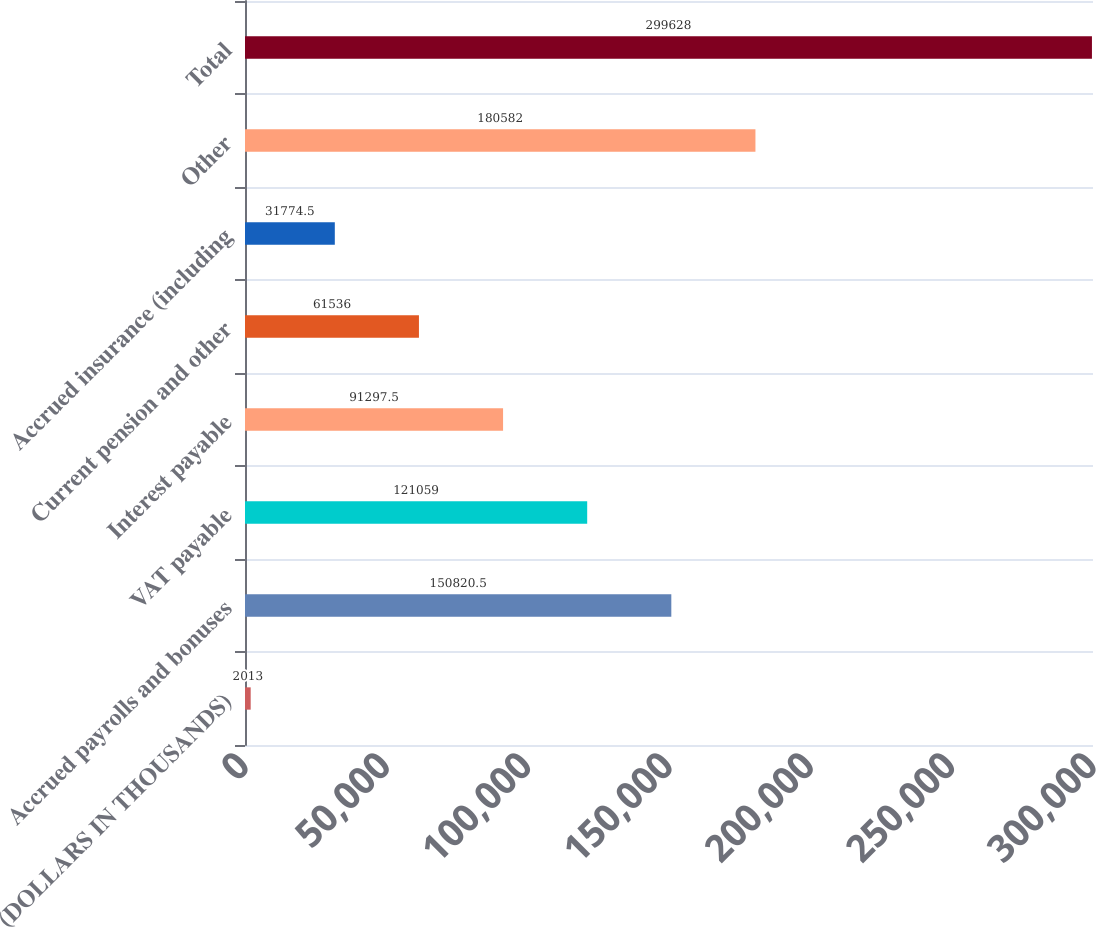Convert chart. <chart><loc_0><loc_0><loc_500><loc_500><bar_chart><fcel>(DOLLARS IN THOUSANDS)<fcel>Accrued payrolls and bonuses<fcel>VAT payable<fcel>Interest payable<fcel>Current pension and other<fcel>Accrued insurance (including<fcel>Other<fcel>Total<nl><fcel>2013<fcel>150820<fcel>121059<fcel>91297.5<fcel>61536<fcel>31774.5<fcel>180582<fcel>299628<nl></chart> 